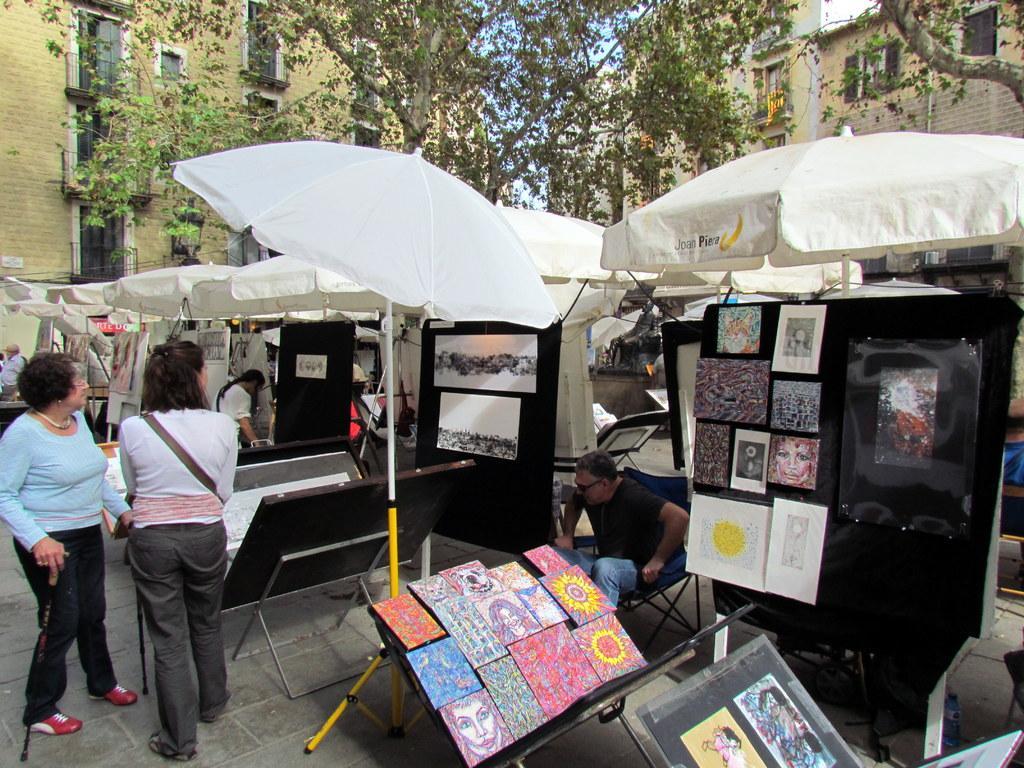Please provide a concise description of this image. This picture describes about group of people few are seated on the chair and few are standing, here we can find couple of arts on the table and an umbrella, in the background we can see couple of buildings and trees. 